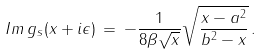Convert formula to latex. <formula><loc_0><loc_0><loc_500><loc_500>I m \, g _ { s } ( x + i \epsilon ) \, = \, - { \frac { 1 } { 8 \beta \sqrt { x } } } \sqrt { { \frac { x - a ^ { 2 } } { b ^ { 2 } - x } } } \, .</formula> 